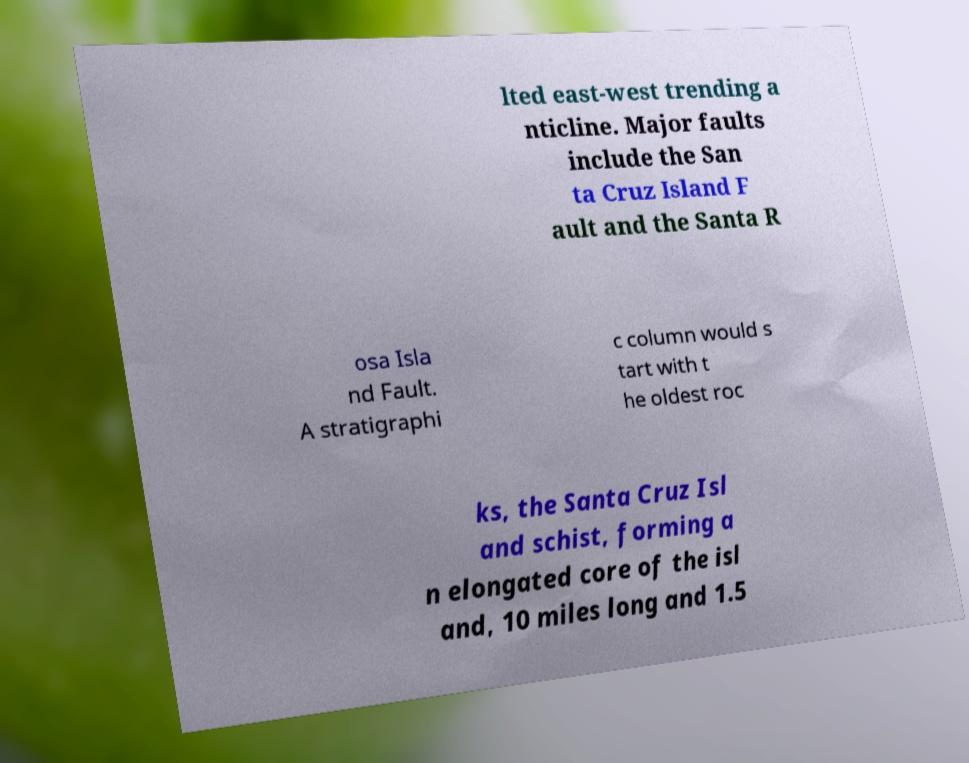For documentation purposes, I need the text within this image transcribed. Could you provide that? lted east-west trending a nticline. Major faults include the San ta Cruz Island F ault and the Santa R osa Isla nd Fault. A stratigraphi c column would s tart with t he oldest roc ks, the Santa Cruz Isl and schist, forming a n elongated core of the isl and, 10 miles long and 1.5 